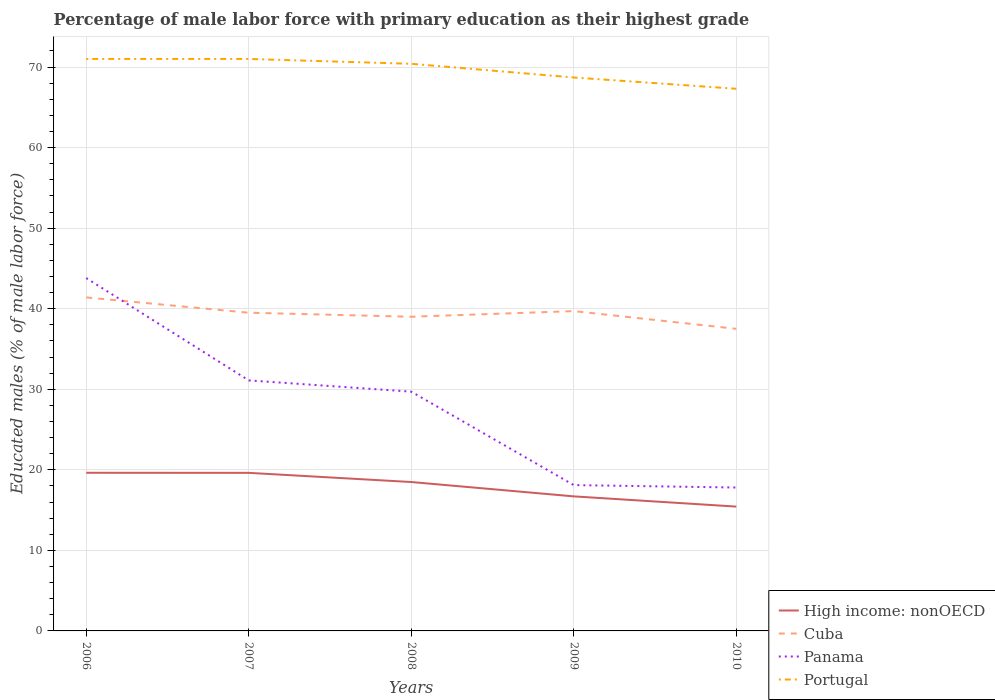Across all years, what is the maximum percentage of male labor force with primary education in Cuba?
Provide a succinct answer. 37.5. What is the total percentage of male labor force with primary education in High income: nonOECD in the graph?
Give a very brief answer. 1.78. What is the difference between the highest and the second highest percentage of male labor force with primary education in High income: nonOECD?
Your answer should be compact. 4.2. What is the difference between the highest and the lowest percentage of male labor force with primary education in Panama?
Your answer should be very brief. 3. How many lines are there?
Offer a terse response. 4. How many legend labels are there?
Keep it short and to the point. 4. How are the legend labels stacked?
Give a very brief answer. Vertical. What is the title of the graph?
Ensure brevity in your answer.  Percentage of male labor force with primary education as their highest grade. What is the label or title of the X-axis?
Offer a very short reply. Years. What is the label or title of the Y-axis?
Make the answer very short. Educated males (% of male labor force). What is the Educated males (% of male labor force) in High income: nonOECD in 2006?
Your answer should be very brief. 19.63. What is the Educated males (% of male labor force) in Cuba in 2006?
Offer a terse response. 41.4. What is the Educated males (% of male labor force) of Panama in 2006?
Your answer should be very brief. 43.8. What is the Educated males (% of male labor force) of Portugal in 2006?
Ensure brevity in your answer.  71. What is the Educated males (% of male labor force) in High income: nonOECD in 2007?
Your answer should be compact. 19.62. What is the Educated males (% of male labor force) in Cuba in 2007?
Offer a very short reply. 39.5. What is the Educated males (% of male labor force) of Panama in 2007?
Give a very brief answer. 31.1. What is the Educated males (% of male labor force) of High income: nonOECD in 2008?
Your response must be concise. 18.48. What is the Educated males (% of male labor force) in Cuba in 2008?
Provide a succinct answer. 39. What is the Educated males (% of male labor force) in Panama in 2008?
Offer a terse response. 29.7. What is the Educated males (% of male labor force) in Portugal in 2008?
Keep it short and to the point. 70.4. What is the Educated males (% of male labor force) in High income: nonOECD in 2009?
Your answer should be compact. 16.7. What is the Educated males (% of male labor force) in Cuba in 2009?
Offer a very short reply. 39.7. What is the Educated males (% of male labor force) of Panama in 2009?
Provide a succinct answer. 18.1. What is the Educated males (% of male labor force) of Portugal in 2009?
Your answer should be very brief. 68.7. What is the Educated males (% of male labor force) in High income: nonOECD in 2010?
Make the answer very short. 15.43. What is the Educated males (% of male labor force) of Cuba in 2010?
Offer a very short reply. 37.5. What is the Educated males (% of male labor force) of Panama in 2010?
Provide a succinct answer. 17.8. What is the Educated males (% of male labor force) in Portugal in 2010?
Your answer should be compact. 67.3. Across all years, what is the maximum Educated males (% of male labor force) of High income: nonOECD?
Provide a short and direct response. 19.63. Across all years, what is the maximum Educated males (% of male labor force) in Cuba?
Your response must be concise. 41.4. Across all years, what is the maximum Educated males (% of male labor force) in Panama?
Provide a short and direct response. 43.8. Across all years, what is the maximum Educated males (% of male labor force) of Portugal?
Offer a very short reply. 71. Across all years, what is the minimum Educated males (% of male labor force) of High income: nonOECD?
Ensure brevity in your answer.  15.43. Across all years, what is the minimum Educated males (% of male labor force) of Cuba?
Offer a very short reply. 37.5. Across all years, what is the minimum Educated males (% of male labor force) of Panama?
Give a very brief answer. 17.8. Across all years, what is the minimum Educated males (% of male labor force) in Portugal?
Offer a very short reply. 67.3. What is the total Educated males (% of male labor force) in High income: nonOECD in the graph?
Offer a terse response. 89.87. What is the total Educated males (% of male labor force) in Cuba in the graph?
Give a very brief answer. 197.1. What is the total Educated males (% of male labor force) of Panama in the graph?
Give a very brief answer. 140.5. What is the total Educated males (% of male labor force) in Portugal in the graph?
Keep it short and to the point. 348.4. What is the difference between the Educated males (% of male labor force) of High income: nonOECD in 2006 and that in 2007?
Your response must be concise. 0.01. What is the difference between the Educated males (% of male labor force) in Portugal in 2006 and that in 2007?
Your answer should be compact. 0. What is the difference between the Educated males (% of male labor force) of High income: nonOECD in 2006 and that in 2008?
Offer a terse response. 1.15. What is the difference between the Educated males (% of male labor force) of Cuba in 2006 and that in 2008?
Your response must be concise. 2.4. What is the difference between the Educated males (% of male labor force) in High income: nonOECD in 2006 and that in 2009?
Give a very brief answer. 2.93. What is the difference between the Educated males (% of male labor force) in Cuba in 2006 and that in 2009?
Your answer should be compact. 1.7. What is the difference between the Educated males (% of male labor force) in Panama in 2006 and that in 2009?
Your answer should be very brief. 25.7. What is the difference between the Educated males (% of male labor force) of High income: nonOECD in 2006 and that in 2010?
Your response must be concise. 4.2. What is the difference between the Educated males (% of male labor force) in Cuba in 2006 and that in 2010?
Provide a succinct answer. 3.9. What is the difference between the Educated males (% of male labor force) of Portugal in 2006 and that in 2010?
Your response must be concise. 3.7. What is the difference between the Educated males (% of male labor force) in High income: nonOECD in 2007 and that in 2008?
Offer a terse response. 1.14. What is the difference between the Educated males (% of male labor force) of Panama in 2007 and that in 2008?
Offer a very short reply. 1.4. What is the difference between the Educated males (% of male labor force) of High income: nonOECD in 2007 and that in 2009?
Your answer should be very brief. 2.92. What is the difference between the Educated males (% of male labor force) of Cuba in 2007 and that in 2009?
Your answer should be very brief. -0.2. What is the difference between the Educated males (% of male labor force) of Panama in 2007 and that in 2009?
Your answer should be very brief. 13. What is the difference between the Educated males (% of male labor force) in Portugal in 2007 and that in 2009?
Your answer should be very brief. 2.3. What is the difference between the Educated males (% of male labor force) of High income: nonOECD in 2007 and that in 2010?
Offer a very short reply. 4.19. What is the difference between the Educated males (% of male labor force) of Cuba in 2007 and that in 2010?
Keep it short and to the point. 2. What is the difference between the Educated males (% of male labor force) of Panama in 2007 and that in 2010?
Make the answer very short. 13.3. What is the difference between the Educated males (% of male labor force) of High income: nonOECD in 2008 and that in 2009?
Offer a very short reply. 1.78. What is the difference between the Educated males (% of male labor force) in Panama in 2008 and that in 2009?
Offer a very short reply. 11.6. What is the difference between the Educated males (% of male labor force) in Portugal in 2008 and that in 2009?
Give a very brief answer. 1.7. What is the difference between the Educated males (% of male labor force) of High income: nonOECD in 2008 and that in 2010?
Offer a terse response. 3.05. What is the difference between the Educated males (% of male labor force) in Cuba in 2008 and that in 2010?
Provide a succinct answer. 1.5. What is the difference between the Educated males (% of male labor force) of Portugal in 2008 and that in 2010?
Make the answer very short. 3.1. What is the difference between the Educated males (% of male labor force) of High income: nonOECD in 2009 and that in 2010?
Your response must be concise. 1.27. What is the difference between the Educated males (% of male labor force) in High income: nonOECD in 2006 and the Educated males (% of male labor force) in Cuba in 2007?
Keep it short and to the point. -19.87. What is the difference between the Educated males (% of male labor force) of High income: nonOECD in 2006 and the Educated males (% of male labor force) of Panama in 2007?
Your response must be concise. -11.47. What is the difference between the Educated males (% of male labor force) of High income: nonOECD in 2006 and the Educated males (% of male labor force) of Portugal in 2007?
Provide a short and direct response. -51.37. What is the difference between the Educated males (% of male labor force) of Cuba in 2006 and the Educated males (% of male labor force) of Panama in 2007?
Offer a terse response. 10.3. What is the difference between the Educated males (% of male labor force) of Cuba in 2006 and the Educated males (% of male labor force) of Portugal in 2007?
Keep it short and to the point. -29.6. What is the difference between the Educated males (% of male labor force) in Panama in 2006 and the Educated males (% of male labor force) in Portugal in 2007?
Offer a terse response. -27.2. What is the difference between the Educated males (% of male labor force) in High income: nonOECD in 2006 and the Educated males (% of male labor force) in Cuba in 2008?
Your answer should be compact. -19.37. What is the difference between the Educated males (% of male labor force) of High income: nonOECD in 2006 and the Educated males (% of male labor force) of Panama in 2008?
Give a very brief answer. -10.07. What is the difference between the Educated males (% of male labor force) of High income: nonOECD in 2006 and the Educated males (% of male labor force) of Portugal in 2008?
Give a very brief answer. -50.77. What is the difference between the Educated males (% of male labor force) in Panama in 2006 and the Educated males (% of male labor force) in Portugal in 2008?
Offer a terse response. -26.6. What is the difference between the Educated males (% of male labor force) in High income: nonOECD in 2006 and the Educated males (% of male labor force) in Cuba in 2009?
Your answer should be very brief. -20.07. What is the difference between the Educated males (% of male labor force) in High income: nonOECD in 2006 and the Educated males (% of male labor force) in Panama in 2009?
Your answer should be compact. 1.53. What is the difference between the Educated males (% of male labor force) in High income: nonOECD in 2006 and the Educated males (% of male labor force) in Portugal in 2009?
Make the answer very short. -49.07. What is the difference between the Educated males (% of male labor force) in Cuba in 2006 and the Educated males (% of male labor force) in Panama in 2009?
Offer a very short reply. 23.3. What is the difference between the Educated males (% of male labor force) in Cuba in 2006 and the Educated males (% of male labor force) in Portugal in 2009?
Give a very brief answer. -27.3. What is the difference between the Educated males (% of male labor force) of Panama in 2006 and the Educated males (% of male labor force) of Portugal in 2009?
Your answer should be compact. -24.9. What is the difference between the Educated males (% of male labor force) in High income: nonOECD in 2006 and the Educated males (% of male labor force) in Cuba in 2010?
Keep it short and to the point. -17.87. What is the difference between the Educated males (% of male labor force) of High income: nonOECD in 2006 and the Educated males (% of male labor force) of Panama in 2010?
Give a very brief answer. 1.83. What is the difference between the Educated males (% of male labor force) in High income: nonOECD in 2006 and the Educated males (% of male labor force) in Portugal in 2010?
Provide a short and direct response. -47.67. What is the difference between the Educated males (% of male labor force) of Cuba in 2006 and the Educated males (% of male labor force) of Panama in 2010?
Ensure brevity in your answer.  23.6. What is the difference between the Educated males (% of male labor force) of Cuba in 2006 and the Educated males (% of male labor force) of Portugal in 2010?
Your response must be concise. -25.9. What is the difference between the Educated males (% of male labor force) in Panama in 2006 and the Educated males (% of male labor force) in Portugal in 2010?
Provide a succinct answer. -23.5. What is the difference between the Educated males (% of male labor force) of High income: nonOECD in 2007 and the Educated males (% of male labor force) of Cuba in 2008?
Make the answer very short. -19.38. What is the difference between the Educated males (% of male labor force) of High income: nonOECD in 2007 and the Educated males (% of male labor force) of Panama in 2008?
Offer a terse response. -10.08. What is the difference between the Educated males (% of male labor force) in High income: nonOECD in 2007 and the Educated males (% of male labor force) in Portugal in 2008?
Your answer should be compact. -50.78. What is the difference between the Educated males (% of male labor force) of Cuba in 2007 and the Educated males (% of male labor force) of Portugal in 2008?
Keep it short and to the point. -30.9. What is the difference between the Educated males (% of male labor force) of Panama in 2007 and the Educated males (% of male labor force) of Portugal in 2008?
Make the answer very short. -39.3. What is the difference between the Educated males (% of male labor force) of High income: nonOECD in 2007 and the Educated males (% of male labor force) of Cuba in 2009?
Ensure brevity in your answer.  -20.08. What is the difference between the Educated males (% of male labor force) in High income: nonOECD in 2007 and the Educated males (% of male labor force) in Panama in 2009?
Make the answer very short. 1.52. What is the difference between the Educated males (% of male labor force) of High income: nonOECD in 2007 and the Educated males (% of male labor force) of Portugal in 2009?
Ensure brevity in your answer.  -49.08. What is the difference between the Educated males (% of male labor force) of Cuba in 2007 and the Educated males (% of male labor force) of Panama in 2009?
Make the answer very short. 21.4. What is the difference between the Educated males (% of male labor force) of Cuba in 2007 and the Educated males (% of male labor force) of Portugal in 2009?
Ensure brevity in your answer.  -29.2. What is the difference between the Educated males (% of male labor force) in Panama in 2007 and the Educated males (% of male labor force) in Portugal in 2009?
Ensure brevity in your answer.  -37.6. What is the difference between the Educated males (% of male labor force) in High income: nonOECD in 2007 and the Educated males (% of male labor force) in Cuba in 2010?
Provide a short and direct response. -17.88. What is the difference between the Educated males (% of male labor force) of High income: nonOECD in 2007 and the Educated males (% of male labor force) of Panama in 2010?
Ensure brevity in your answer.  1.82. What is the difference between the Educated males (% of male labor force) in High income: nonOECD in 2007 and the Educated males (% of male labor force) in Portugal in 2010?
Offer a very short reply. -47.68. What is the difference between the Educated males (% of male labor force) of Cuba in 2007 and the Educated males (% of male labor force) of Panama in 2010?
Your response must be concise. 21.7. What is the difference between the Educated males (% of male labor force) in Cuba in 2007 and the Educated males (% of male labor force) in Portugal in 2010?
Offer a terse response. -27.8. What is the difference between the Educated males (% of male labor force) of Panama in 2007 and the Educated males (% of male labor force) of Portugal in 2010?
Your answer should be very brief. -36.2. What is the difference between the Educated males (% of male labor force) in High income: nonOECD in 2008 and the Educated males (% of male labor force) in Cuba in 2009?
Offer a terse response. -21.22. What is the difference between the Educated males (% of male labor force) of High income: nonOECD in 2008 and the Educated males (% of male labor force) of Panama in 2009?
Offer a very short reply. 0.38. What is the difference between the Educated males (% of male labor force) in High income: nonOECD in 2008 and the Educated males (% of male labor force) in Portugal in 2009?
Your answer should be very brief. -50.22. What is the difference between the Educated males (% of male labor force) in Cuba in 2008 and the Educated males (% of male labor force) in Panama in 2009?
Provide a succinct answer. 20.9. What is the difference between the Educated males (% of male labor force) of Cuba in 2008 and the Educated males (% of male labor force) of Portugal in 2009?
Your response must be concise. -29.7. What is the difference between the Educated males (% of male labor force) of Panama in 2008 and the Educated males (% of male labor force) of Portugal in 2009?
Your answer should be very brief. -39. What is the difference between the Educated males (% of male labor force) in High income: nonOECD in 2008 and the Educated males (% of male labor force) in Cuba in 2010?
Make the answer very short. -19.02. What is the difference between the Educated males (% of male labor force) of High income: nonOECD in 2008 and the Educated males (% of male labor force) of Panama in 2010?
Ensure brevity in your answer.  0.68. What is the difference between the Educated males (% of male labor force) in High income: nonOECD in 2008 and the Educated males (% of male labor force) in Portugal in 2010?
Your answer should be very brief. -48.82. What is the difference between the Educated males (% of male labor force) of Cuba in 2008 and the Educated males (% of male labor force) of Panama in 2010?
Offer a very short reply. 21.2. What is the difference between the Educated males (% of male labor force) in Cuba in 2008 and the Educated males (% of male labor force) in Portugal in 2010?
Your answer should be compact. -28.3. What is the difference between the Educated males (% of male labor force) in Panama in 2008 and the Educated males (% of male labor force) in Portugal in 2010?
Offer a terse response. -37.6. What is the difference between the Educated males (% of male labor force) of High income: nonOECD in 2009 and the Educated males (% of male labor force) of Cuba in 2010?
Your response must be concise. -20.8. What is the difference between the Educated males (% of male labor force) in High income: nonOECD in 2009 and the Educated males (% of male labor force) in Panama in 2010?
Offer a terse response. -1.1. What is the difference between the Educated males (% of male labor force) of High income: nonOECD in 2009 and the Educated males (% of male labor force) of Portugal in 2010?
Offer a very short reply. -50.6. What is the difference between the Educated males (% of male labor force) of Cuba in 2009 and the Educated males (% of male labor force) of Panama in 2010?
Your answer should be very brief. 21.9. What is the difference between the Educated males (% of male labor force) in Cuba in 2009 and the Educated males (% of male labor force) in Portugal in 2010?
Provide a succinct answer. -27.6. What is the difference between the Educated males (% of male labor force) in Panama in 2009 and the Educated males (% of male labor force) in Portugal in 2010?
Your answer should be very brief. -49.2. What is the average Educated males (% of male labor force) in High income: nonOECD per year?
Your response must be concise. 17.97. What is the average Educated males (% of male labor force) of Cuba per year?
Your response must be concise. 39.42. What is the average Educated males (% of male labor force) of Panama per year?
Keep it short and to the point. 28.1. What is the average Educated males (% of male labor force) in Portugal per year?
Your response must be concise. 69.68. In the year 2006, what is the difference between the Educated males (% of male labor force) in High income: nonOECD and Educated males (% of male labor force) in Cuba?
Ensure brevity in your answer.  -21.77. In the year 2006, what is the difference between the Educated males (% of male labor force) of High income: nonOECD and Educated males (% of male labor force) of Panama?
Your answer should be very brief. -24.17. In the year 2006, what is the difference between the Educated males (% of male labor force) in High income: nonOECD and Educated males (% of male labor force) in Portugal?
Ensure brevity in your answer.  -51.37. In the year 2006, what is the difference between the Educated males (% of male labor force) of Cuba and Educated males (% of male labor force) of Portugal?
Offer a terse response. -29.6. In the year 2006, what is the difference between the Educated males (% of male labor force) in Panama and Educated males (% of male labor force) in Portugal?
Provide a short and direct response. -27.2. In the year 2007, what is the difference between the Educated males (% of male labor force) of High income: nonOECD and Educated males (% of male labor force) of Cuba?
Make the answer very short. -19.88. In the year 2007, what is the difference between the Educated males (% of male labor force) of High income: nonOECD and Educated males (% of male labor force) of Panama?
Make the answer very short. -11.48. In the year 2007, what is the difference between the Educated males (% of male labor force) in High income: nonOECD and Educated males (% of male labor force) in Portugal?
Give a very brief answer. -51.38. In the year 2007, what is the difference between the Educated males (% of male labor force) of Cuba and Educated males (% of male labor force) of Panama?
Your response must be concise. 8.4. In the year 2007, what is the difference between the Educated males (% of male labor force) in Cuba and Educated males (% of male labor force) in Portugal?
Provide a succinct answer. -31.5. In the year 2007, what is the difference between the Educated males (% of male labor force) in Panama and Educated males (% of male labor force) in Portugal?
Your response must be concise. -39.9. In the year 2008, what is the difference between the Educated males (% of male labor force) in High income: nonOECD and Educated males (% of male labor force) in Cuba?
Your answer should be very brief. -20.52. In the year 2008, what is the difference between the Educated males (% of male labor force) of High income: nonOECD and Educated males (% of male labor force) of Panama?
Your answer should be very brief. -11.22. In the year 2008, what is the difference between the Educated males (% of male labor force) of High income: nonOECD and Educated males (% of male labor force) of Portugal?
Offer a terse response. -51.92. In the year 2008, what is the difference between the Educated males (% of male labor force) of Cuba and Educated males (% of male labor force) of Panama?
Make the answer very short. 9.3. In the year 2008, what is the difference between the Educated males (% of male labor force) in Cuba and Educated males (% of male labor force) in Portugal?
Provide a short and direct response. -31.4. In the year 2008, what is the difference between the Educated males (% of male labor force) in Panama and Educated males (% of male labor force) in Portugal?
Keep it short and to the point. -40.7. In the year 2009, what is the difference between the Educated males (% of male labor force) of High income: nonOECD and Educated males (% of male labor force) of Cuba?
Provide a short and direct response. -23. In the year 2009, what is the difference between the Educated males (% of male labor force) in High income: nonOECD and Educated males (% of male labor force) in Panama?
Give a very brief answer. -1.4. In the year 2009, what is the difference between the Educated males (% of male labor force) in High income: nonOECD and Educated males (% of male labor force) in Portugal?
Your answer should be compact. -52. In the year 2009, what is the difference between the Educated males (% of male labor force) in Cuba and Educated males (% of male labor force) in Panama?
Provide a succinct answer. 21.6. In the year 2009, what is the difference between the Educated males (% of male labor force) of Panama and Educated males (% of male labor force) of Portugal?
Offer a very short reply. -50.6. In the year 2010, what is the difference between the Educated males (% of male labor force) in High income: nonOECD and Educated males (% of male labor force) in Cuba?
Give a very brief answer. -22.07. In the year 2010, what is the difference between the Educated males (% of male labor force) in High income: nonOECD and Educated males (% of male labor force) in Panama?
Make the answer very short. -2.37. In the year 2010, what is the difference between the Educated males (% of male labor force) of High income: nonOECD and Educated males (% of male labor force) of Portugal?
Provide a succinct answer. -51.87. In the year 2010, what is the difference between the Educated males (% of male labor force) in Cuba and Educated males (% of male labor force) in Panama?
Provide a short and direct response. 19.7. In the year 2010, what is the difference between the Educated males (% of male labor force) of Cuba and Educated males (% of male labor force) of Portugal?
Your answer should be very brief. -29.8. In the year 2010, what is the difference between the Educated males (% of male labor force) of Panama and Educated males (% of male labor force) of Portugal?
Give a very brief answer. -49.5. What is the ratio of the Educated males (% of male labor force) in Cuba in 2006 to that in 2007?
Make the answer very short. 1.05. What is the ratio of the Educated males (% of male labor force) in Panama in 2006 to that in 2007?
Your response must be concise. 1.41. What is the ratio of the Educated males (% of male labor force) in High income: nonOECD in 2006 to that in 2008?
Offer a terse response. 1.06. What is the ratio of the Educated males (% of male labor force) of Cuba in 2006 to that in 2008?
Your response must be concise. 1.06. What is the ratio of the Educated males (% of male labor force) of Panama in 2006 to that in 2008?
Ensure brevity in your answer.  1.47. What is the ratio of the Educated males (% of male labor force) of Portugal in 2006 to that in 2008?
Keep it short and to the point. 1.01. What is the ratio of the Educated males (% of male labor force) of High income: nonOECD in 2006 to that in 2009?
Make the answer very short. 1.18. What is the ratio of the Educated males (% of male labor force) in Cuba in 2006 to that in 2009?
Make the answer very short. 1.04. What is the ratio of the Educated males (% of male labor force) of Panama in 2006 to that in 2009?
Offer a terse response. 2.42. What is the ratio of the Educated males (% of male labor force) in Portugal in 2006 to that in 2009?
Offer a terse response. 1.03. What is the ratio of the Educated males (% of male labor force) in High income: nonOECD in 2006 to that in 2010?
Provide a short and direct response. 1.27. What is the ratio of the Educated males (% of male labor force) of Cuba in 2006 to that in 2010?
Your response must be concise. 1.1. What is the ratio of the Educated males (% of male labor force) in Panama in 2006 to that in 2010?
Offer a terse response. 2.46. What is the ratio of the Educated males (% of male labor force) in Portugal in 2006 to that in 2010?
Ensure brevity in your answer.  1.05. What is the ratio of the Educated males (% of male labor force) in High income: nonOECD in 2007 to that in 2008?
Make the answer very short. 1.06. What is the ratio of the Educated males (% of male labor force) of Cuba in 2007 to that in 2008?
Provide a succinct answer. 1.01. What is the ratio of the Educated males (% of male labor force) of Panama in 2007 to that in 2008?
Your answer should be compact. 1.05. What is the ratio of the Educated males (% of male labor force) of Portugal in 2007 to that in 2008?
Offer a terse response. 1.01. What is the ratio of the Educated males (% of male labor force) in High income: nonOECD in 2007 to that in 2009?
Provide a succinct answer. 1.17. What is the ratio of the Educated males (% of male labor force) of Cuba in 2007 to that in 2009?
Your response must be concise. 0.99. What is the ratio of the Educated males (% of male labor force) in Panama in 2007 to that in 2009?
Your response must be concise. 1.72. What is the ratio of the Educated males (% of male labor force) of Portugal in 2007 to that in 2009?
Provide a short and direct response. 1.03. What is the ratio of the Educated males (% of male labor force) of High income: nonOECD in 2007 to that in 2010?
Your answer should be very brief. 1.27. What is the ratio of the Educated males (% of male labor force) in Cuba in 2007 to that in 2010?
Keep it short and to the point. 1.05. What is the ratio of the Educated males (% of male labor force) of Panama in 2007 to that in 2010?
Provide a short and direct response. 1.75. What is the ratio of the Educated males (% of male labor force) in Portugal in 2007 to that in 2010?
Offer a terse response. 1.05. What is the ratio of the Educated males (% of male labor force) in High income: nonOECD in 2008 to that in 2009?
Keep it short and to the point. 1.11. What is the ratio of the Educated males (% of male labor force) of Cuba in 2008 to that in 2009?
Provide a succinct answer. 0.98. What is the ratio of the Educated males (% of male labor force) in Panama in 2008 to that in 2009?
Offer a terse response. 1.64. What is the ratio of the Educated males (% of male labor force) of Portugal in 2008 to that in 2009?
Your answer should be very brief. 1.02. What is the ratio of the Educated males (% of male labor force) of High income: nonOECD in 2008 to that in 2010?
Your answer should be very brief. 1.2. What is the ratio of the Educated males (% of male labor force) of Panama in 2008 to that in 2010?
Ensure brevity in your answer.  1.67. What is the ratio of the Educated males (% of male labor force) in Portugal in 2008 to that in 2010?
Your answer should be compact. 1.05. What is the ratio of the Educated males (% of male labor force) of High income: nonOECD in 2009 to that in 2010?
Keep it short and to the point. 1.08. What is the ratio of the Educated males (% of male labor force) of Cuba in 2009 to that in 2010?
Make the answer very short. 1.06. What is the ratio of the Educated males (% of male labor force) of Panama in 2009 to that in 2010?
Your answer should be compact. 1.02. What is the ratio of the Educated males (% of male labor force) of Portugal in 2009 to that in 2010?
Provide a short and direct response. 1.02. What is the difference between the highest and the second highest Educated males (% of male labor force) of High income: nonOECD?
Keep it short and to the point. 0.01. What is the difference between the highest and the second highest Educated males (% of male labor force) of Cuba?
Your answer should be very brief. 1.7. What is the difference between the highest and the second highest Educated males (% of male labor force) of Panama?
Give a very brief answer. 12.7. What is the difference between the highest and the lowest Educated males (% of male labor force) of High income: nonOECD?
Provide a succinct answer. 4.2. What is the difference between the highest and the lowest Educated males (% of male labor force) in Cuba?
Your answer should be compact. 3.9. What is the difference between the highest and the lowest Educated males (% of male labor force) of Panama?
Ensure brevity in your answer.  26. 